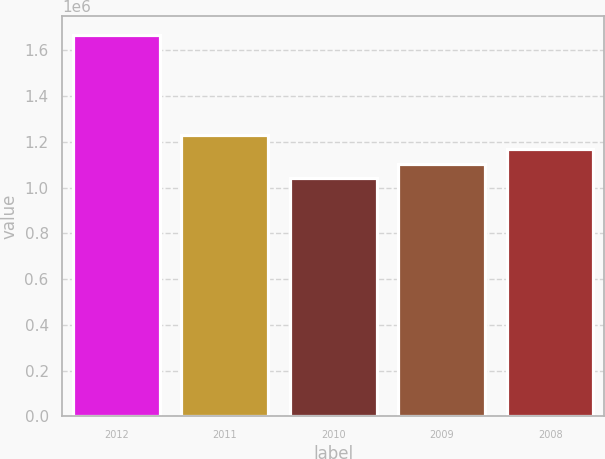Convert chart to OTSL. <chart><loc_0><loc_0><loc_500><loc_500><bar_chart><fcel>2012<fcel>2011<fcel>2010<fcel>2009<fcel>2008<nl><fcel>1.667e+06<fcel>1.2302e+06<fcel>1.043e+06<fcel>1.1054e+06<fcel>1.1678e+06<nl></chart> 